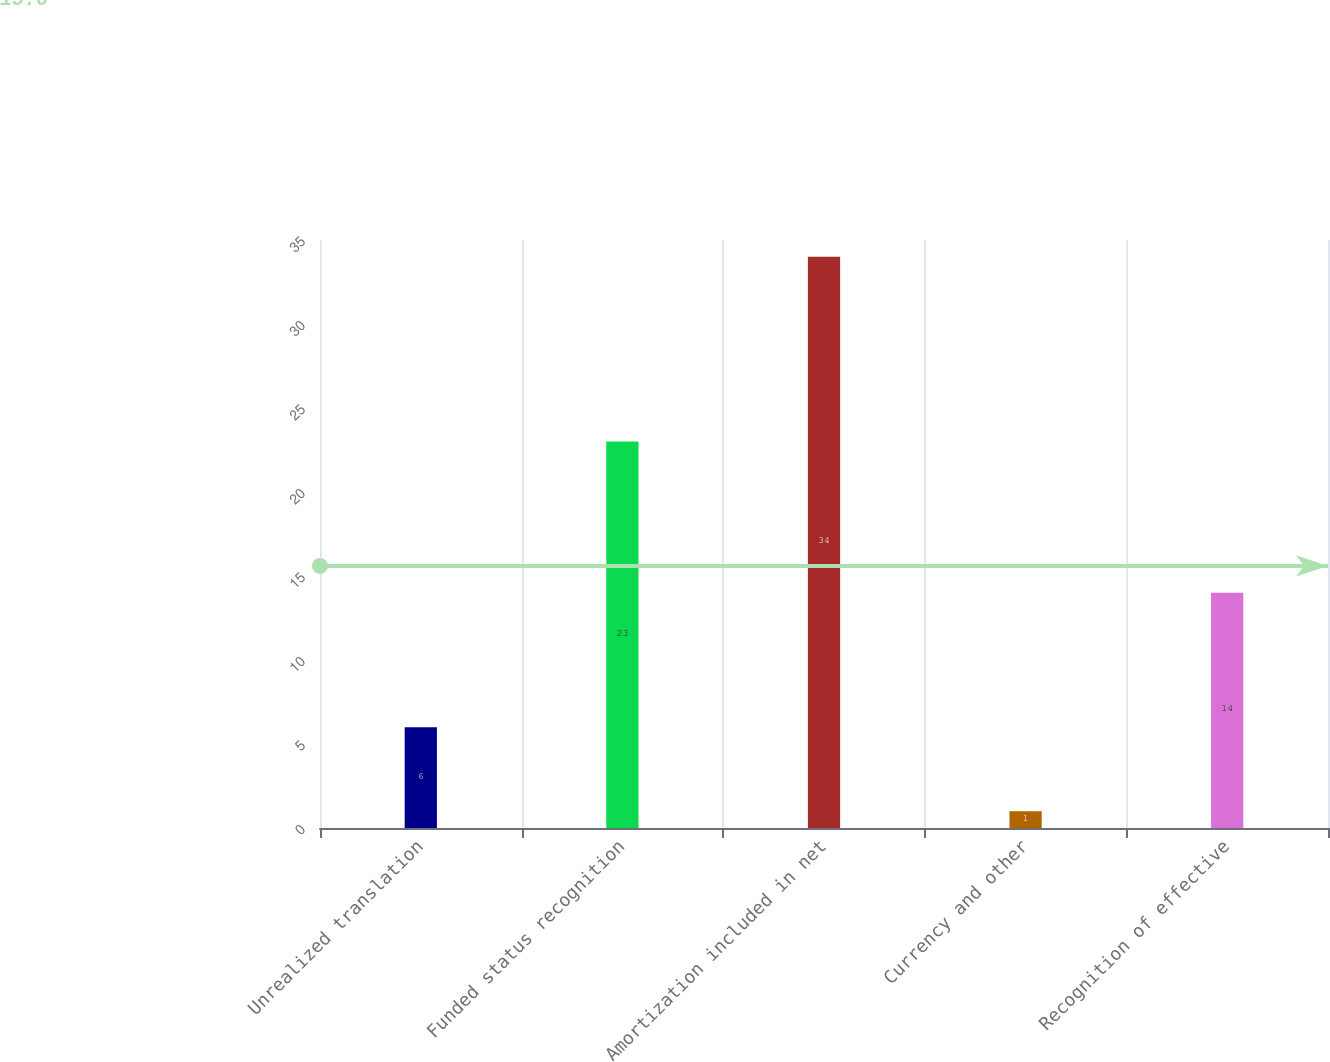<chart> <loc_0><loc_0><loc_500><loc_500><bar_chart><fcel>Unrealized translation<fcel>Funded status recognition<fcel>Amortization included in net<fcel>Currency and other<fcel>Recognition of effective<nl><fcel>6<fcel>23<fcel>34<fcel>1<fcel>14<nl></chart> 